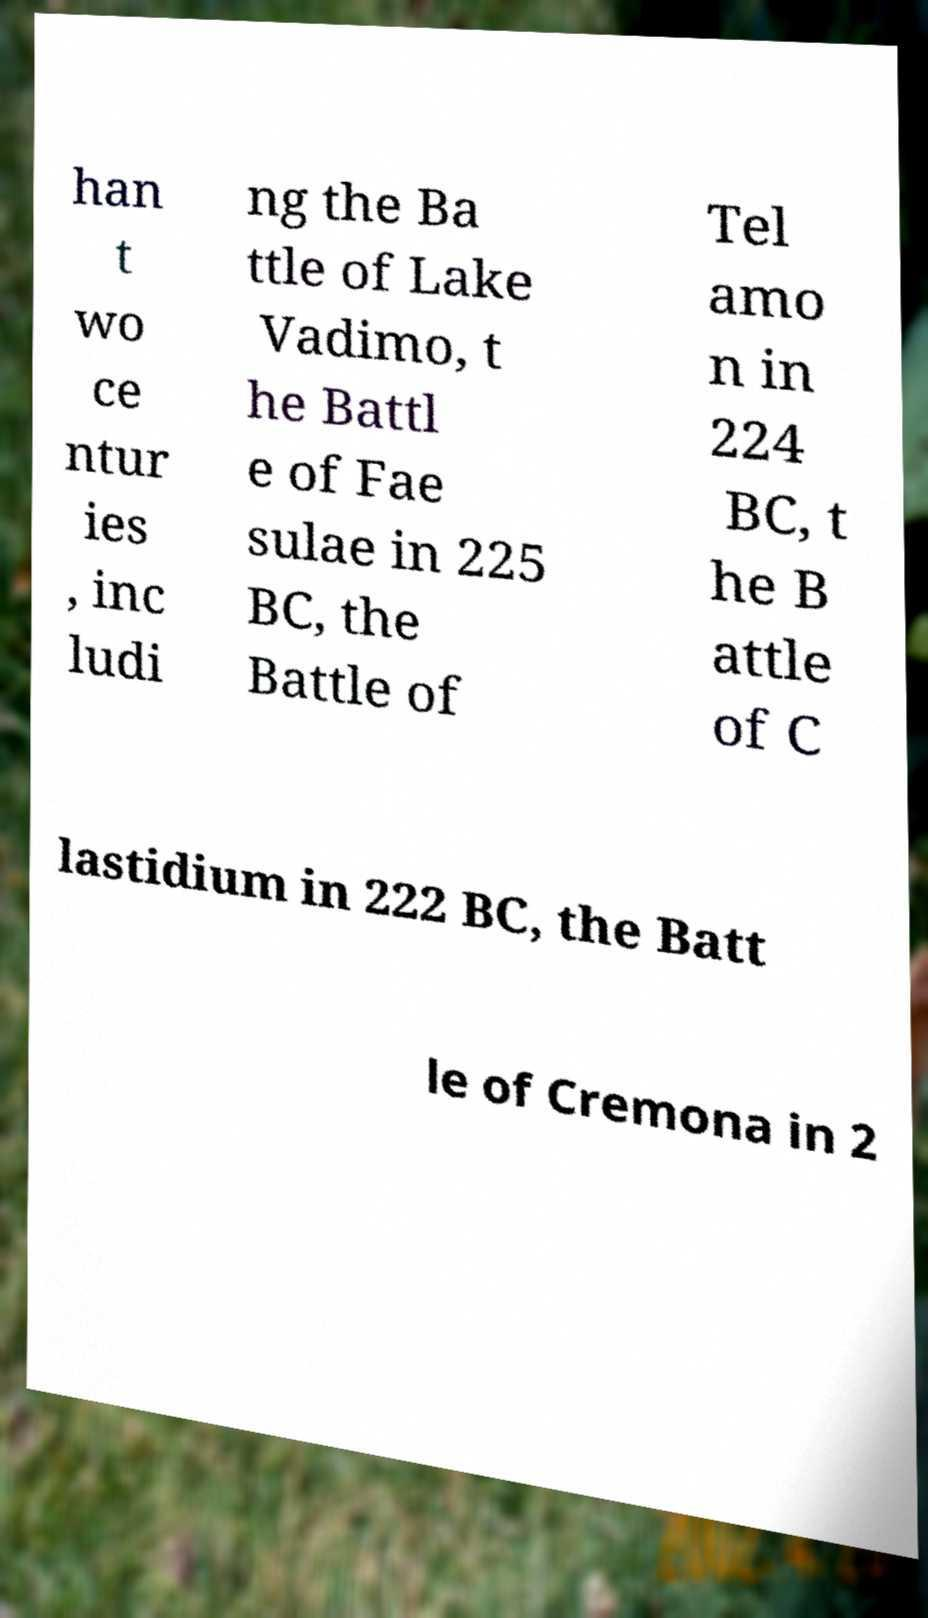Please read and relay the text visible in this image. What does it say? han t wo ce ntur ies , inc ludi ng the Ba ttle of Lake Vadimo, t he Battl e of Fae sulae in 225 BC, the Battle of Tel amo n in 224 BC, t he B attle of C lastidium in 222 BC, the Batt le of Cremona in 2 